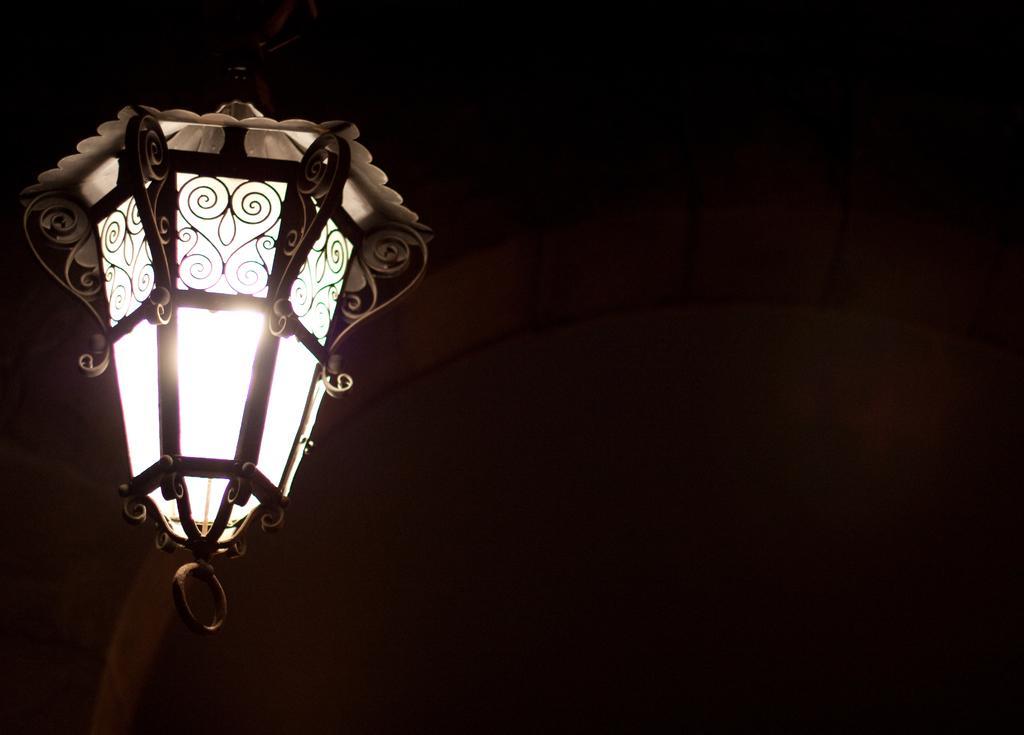Could you give a brief overview of what you see in this image? In this image on the left side there is one light, and in the background there is wall. 